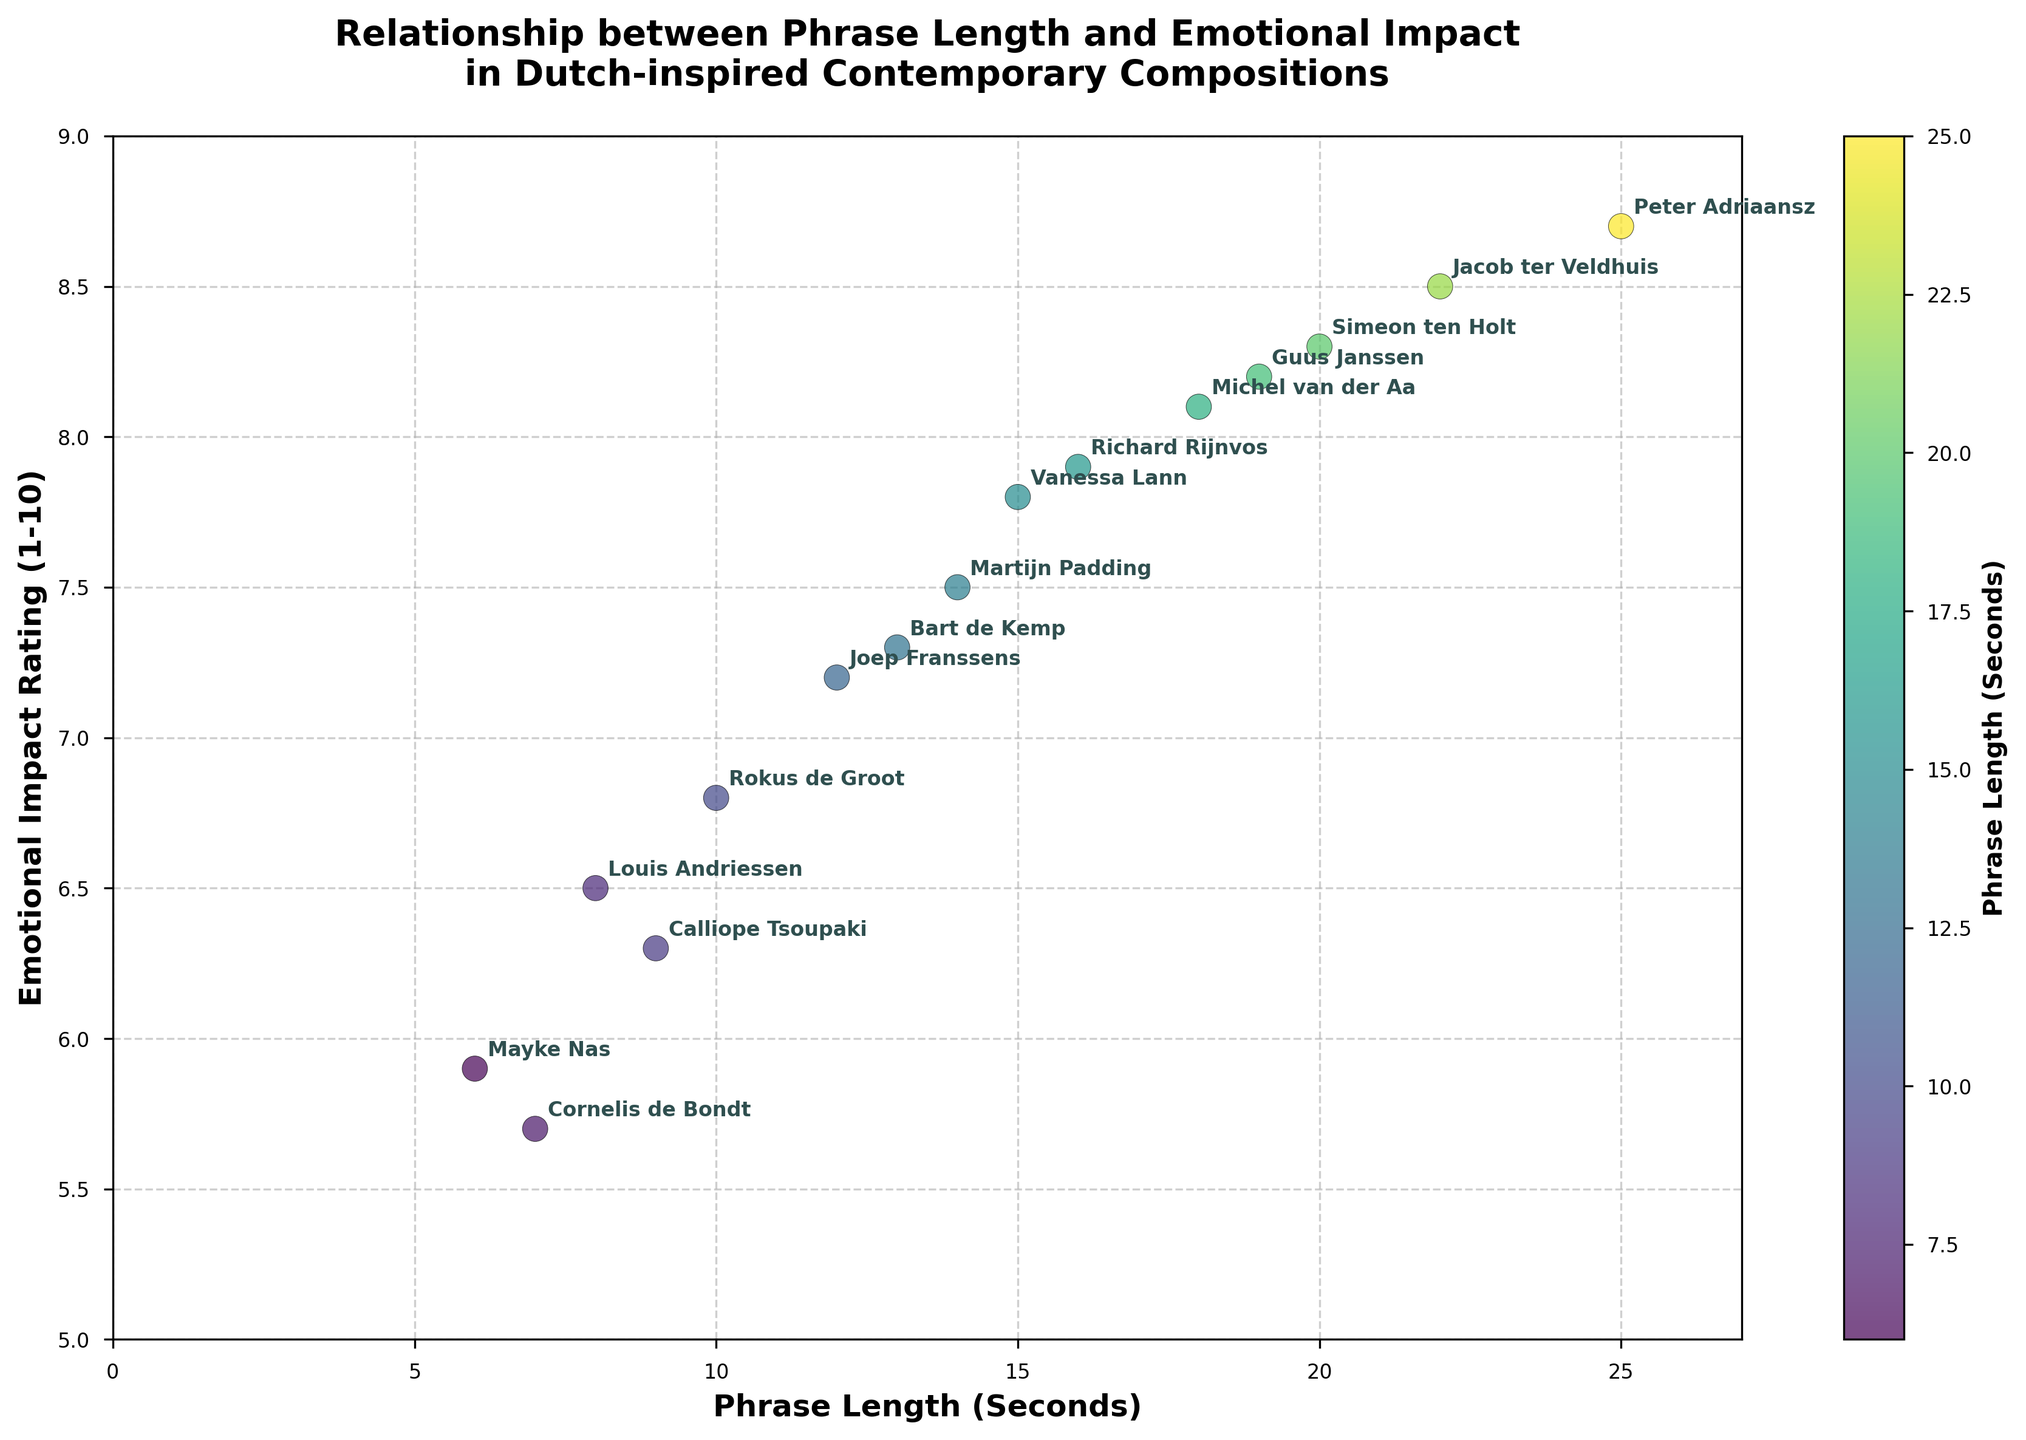What is the title of the figure? The title is prominently placed at the top of the figure. It reads, "Relationship between Phrase Length and Emotional Impact in Dutch-inspired Contemporary Compositions."
Answer: Relationship between Phrase Length and Emotional Impact in Dutch-inspired Contemporary Compositions How many composers are represented in the scatter plot? Each data point corresponds to a different composer, and there are 15 individual data points in the plot.
Answer: 15 What is the emotional impact rating of the composition with the shortest phrase length? The phrase length is plotted on the x-axis, and the smallest value is 6 seconds. The corresponding emotional impact rating on the y-axis for Mayke Nas, who has the shortest phrase length, is 5.9.
Answer: 5.9 Which composer has the highest emotional impact rating according to the plot? By looking at the y-axis for the highest value, Peter Adriaansz has the highest rating of 8.7, corresponding to his 25-second phrase length.
Answer: Peter Adriaansz What is the mean emotional impact rating of all the compositions? Add up all the emotional impact ratings: 7.2 + 6.5 + 8.3 + 7.8 + 5.9 + 8.1 + 6.8 + 8.7 + 7.5 + 6.3 + 8.5 + 7.9 + 5.7 + 8.2 + 7.3 = 111.7. Then divide by the number of composers (15). The mean is 111.7 / 15 = 7.45.
Answer: 7.45 Is there a correlation between phrase length and emotional impact rating? The data points generally show a trend that as the phrase length increases, the emotional impact rating tends to increase. This suggests a positive correlation between the two variables.
Answer: Yes, there is a positive correlation Which composers have an emotional impact rating of 8.5 or higher? Look at the y-axis for ratings of 8.5 and above. The composers who meet this criterion are Simeon ten Holt (8.3), Michel van der Aa (8.1), Peter Adriaansz (8.7), Jacob ter Veldhuis (8.5), and Guus Janssen (8.2). However, only Peter Adriaansz and Jacob ter Veldhuis have ratings of 8.5 or higher.
Answer: Peter Adriaansz, Jacob ter Veldhuis What is the range of phrase lengths in the compositions? The shortest phrase length is 6 seconds (Mayke Nas), and the longest is 25 seconds (Peter Adriaansz). The range is calculated as 25 - 6 = 19 seconds.
Answer: 19 seconds Which composer's work has a phrase length closest to the median value? Arrange the phrase lengths in ascending order: 6, 7, 8, 9, 10, 12, 13, 14, 15, 16, 18, 19, 20, 22, 25. The median value is the 8th data point, which is 14 seconds (Martijn Padding).
Answer: Martijn Padding Is there an outlier in terms of phrase length? To identify an outlier, we look for any data point that significantly differs from the others. Mayke Nas with a phrase length of 6 seconds and Peter Adriaansz with a phrase length of 25 seconds are potential outliers. However, without further statistical analysis (like calculating the interquartile range), it's hard to definitively state.
Answer: Mayke Nas and Peter Adriaansz (potential) 